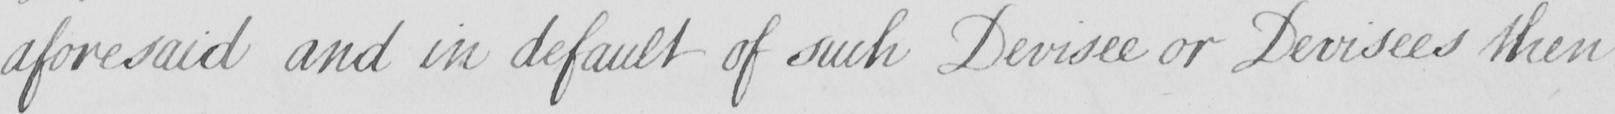Transcribe the text shown in this historical manuscript line. aforesaid and in default of such Devisee or Devisees then 